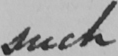Can you read and transcribe this handwriting? such 